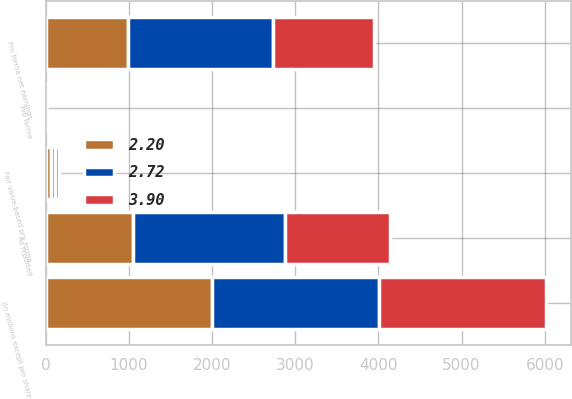Convert chart to OTSL. <chart><loc_0><loc_0><loc_500><loc_500><stacked_bar_chart><ecel><fcel>(In millions except per share<fcel>As reported<fcel>Fair value-based pro forma<fcel>Pro forma net earnings<fcel>Pro forma<nl><fcel>2.72<fcel>2005<fcel>1825<fcel>56<fcel>1736<fcel>3.95<nl><fcel>3.9<fcel>2004<fcel>1266<fcel>48<fcel>1218<fcel>2.75<nl><fcel>2.2<fcel>2003<fcel>1053<fcel>61<fcel>992<fcel>2.22<nl></chart> 